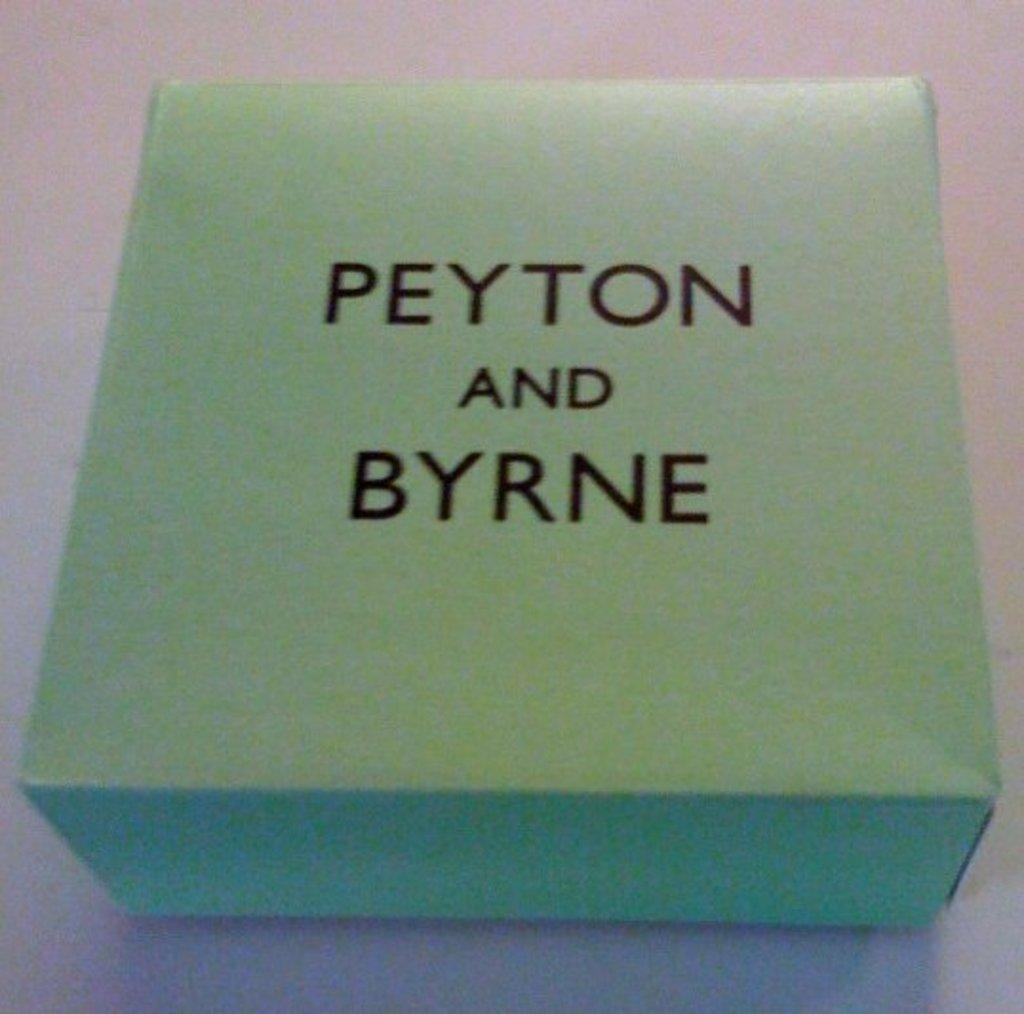<image>
Provide a brief description of the given image. A green square box with the wording Peyton and Byrne. 